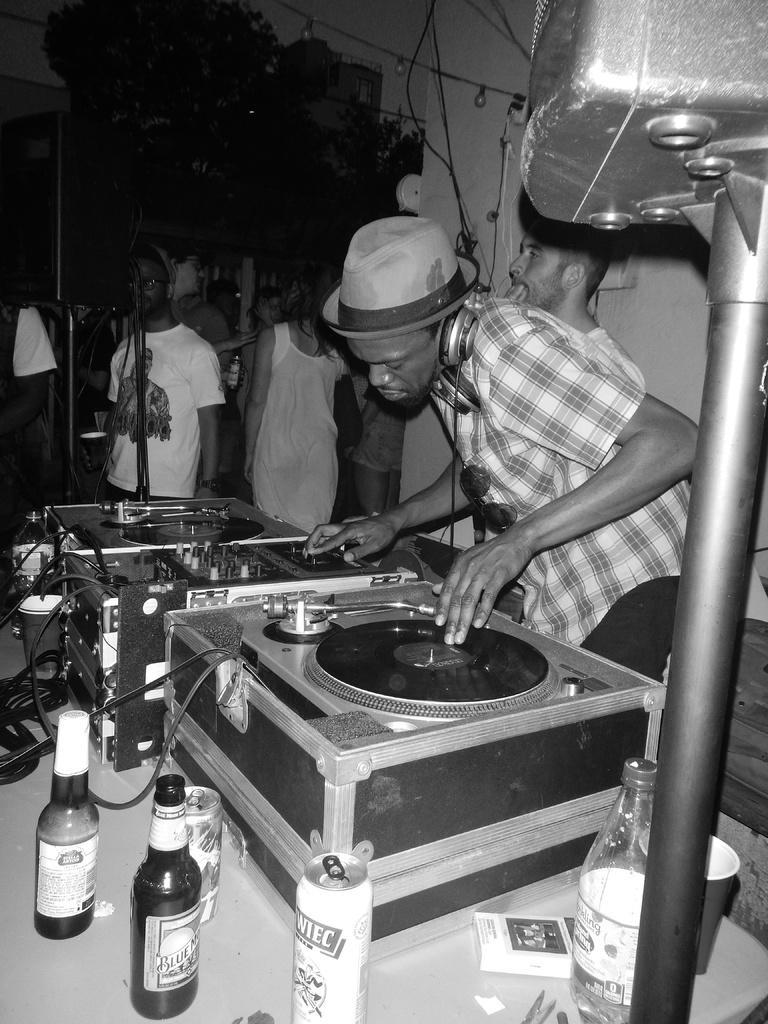Can you describe this image briefly? This is a black and white image which is clicked inside. In the foreground there is a table on the top of which devices, bottles, cans and other items are placed. On the right there is a person wearing headphones and standing and we can we see a metal rod and an object attached to the metal rod. In the background we can see the group of people and cables and many other items. 